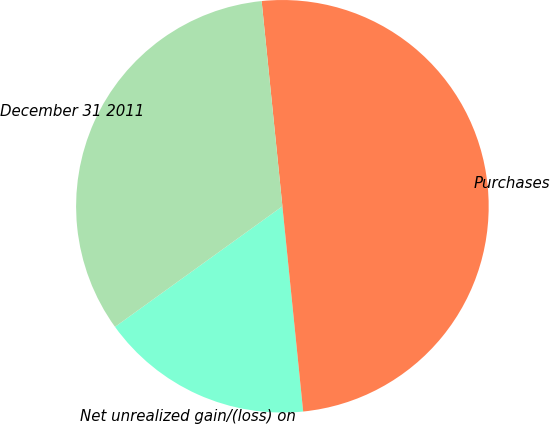<chart> <loc_0><loc_0><loc_500><loc_500><pie_chart><fcel>Net unrealized gain/(loss) on<fcel>Purchases<fcel>December 31 2011<nl><fcel>16.67%<fcel>50.0%<fcel>33.33%<nl></chart> 